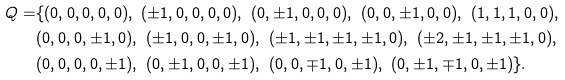Convert formula to latex. <formula><loc_0><loc_0><loc_500><loc_500>Q = & \{ ( 0 , 0 , 0 , 0 , 0 ) , \ ( \pm 1 , 0 , 0 , 0 , 0 ) , \ ( 0 , \pm 1 , 0 , 0 , 0 ) , \ ( 0 , 0 , \pm 1 , 0 , 0 ) , \ ( 1 , 1 , 1 , 0 , 0 ) , \\ & ( 0 , 0 , 0 , \pm 1 , 0 ) , \ ( \pm 1 , 0 , 0 , \pm 1 , 0 ) , \ ( \pm 1 , \pm 1 , \pm 1 , \pm 1 , 0 ) , \ ( \pm 2 , \pm 1 , \pm 1 , \pm 1 , 0 ) , \\ & ( 0 , 0 , 0 , 0 , \pm 1 ) , \ ( 0 , \pm 1 , 0 , 0 , \pm 1 ) , \ ( 0 , 0 , \mp 1 , 0 , \pm 1 ) , \ ( 0 , \pm 1 , \mp 1 , 0 , \pm 1 ) \} .</formula> 